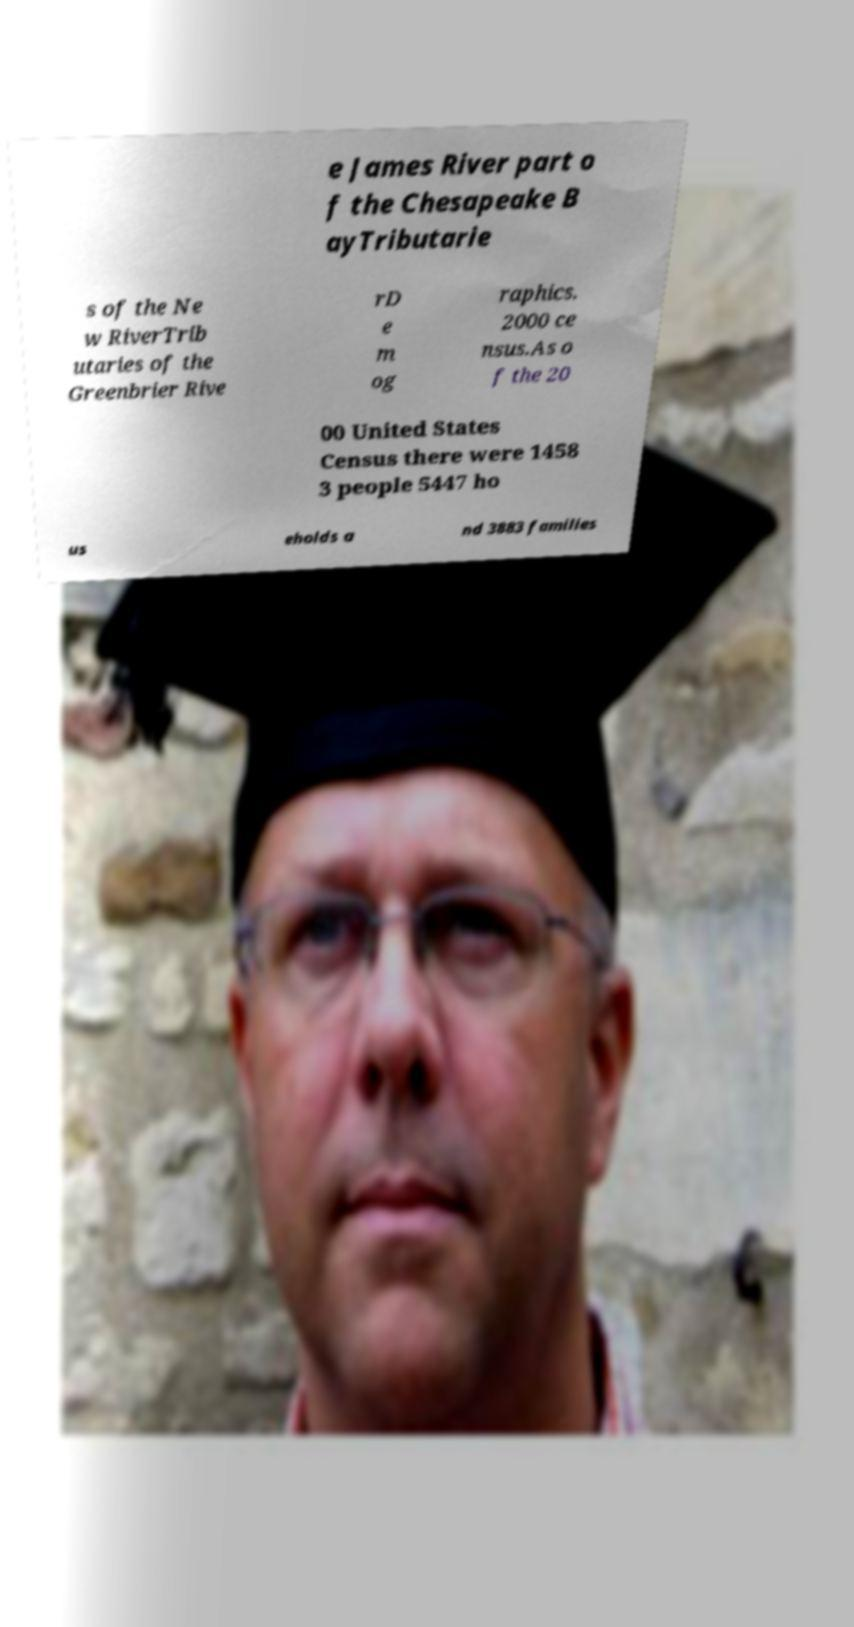For documentation purposes, I need the text within this image transcribed. Could you provide that? e James River part o f the Chesapeake B ayTributarie s of the Ne w RiverTrib utaries of the Greenbrier Rive rD e m og raphics. 2000 ce nsus.As o f the 20 00 United States Census there were 1458 3 people 5447 ho us eholds a nd 3883 families 